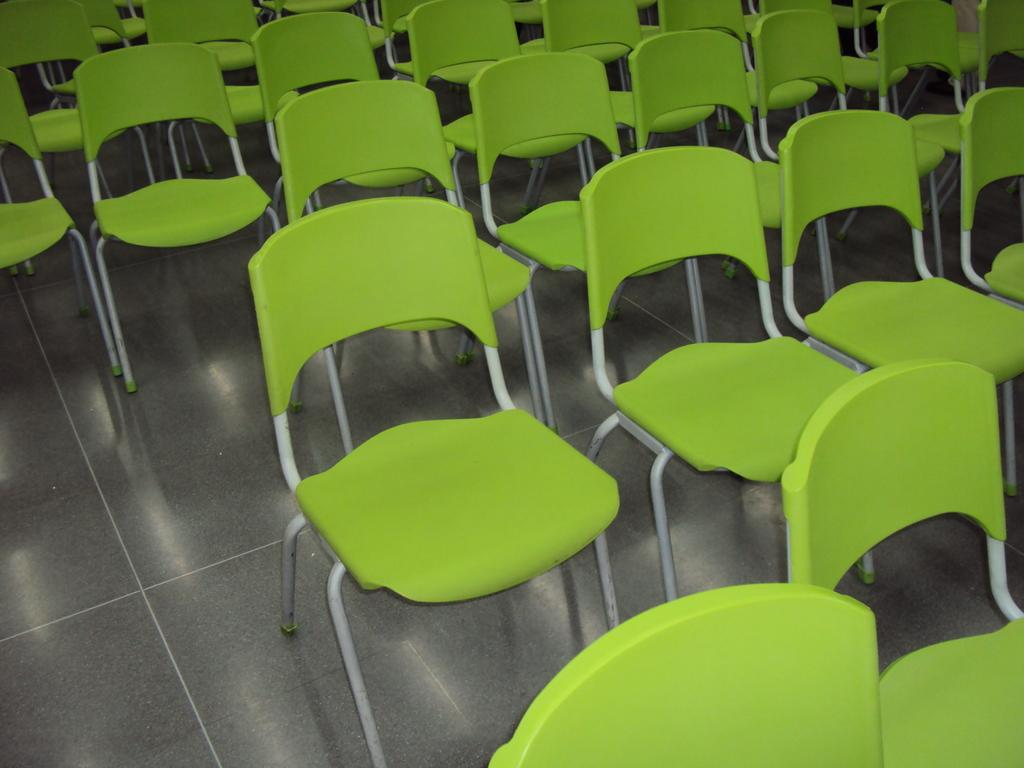What objects are present in the image that are typically used for sitting? There are empty chairs in the image. Where are the chairs located in the image? The chairs are on the floor. What type of friend is sitting next to the secretary in the image? There is no friend or secretary present in the image; it only features empty chairs on the floor. 